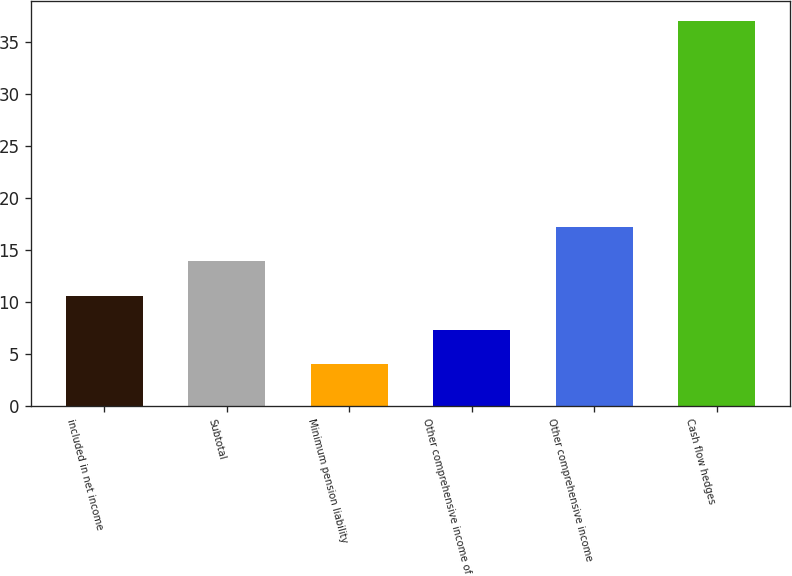<chart> <loc_0><loc_0><loc_500><loc_500><bar_chart><fcel>included in net income<fcel>Subtotal<fcel>Minimum pension liability<fcel>Other comprehensive income of<fcel>Other comprehensive income<fcel>Cash flow hedges<nl><fcel>10.6<fcel>13.9<fcel>4<fcel>7.3<fcel>17.2<fcel>37<nl></chart> 